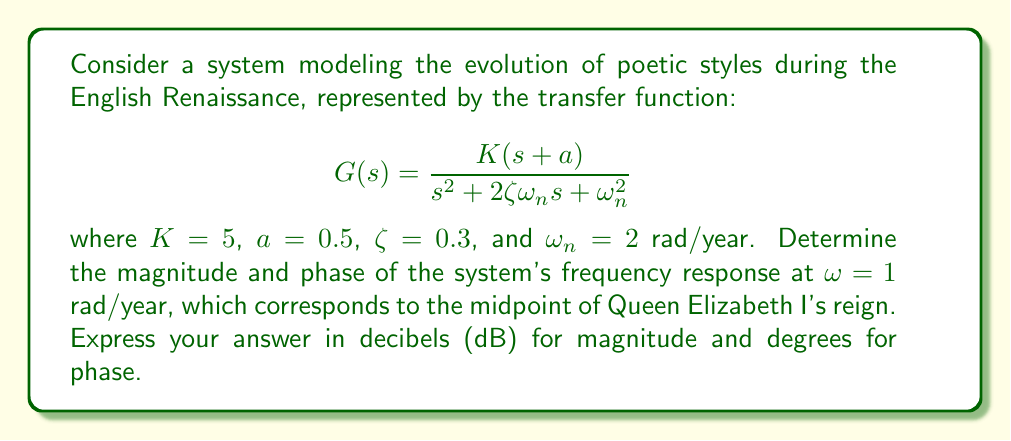Give your solution to this math problem. To solve this problem, we'll follow these steps:

1) The frequency response of a system is given by evaluating its transfer function at $s = j\omega$. Here, we need to evaluate $G(j\omega)$ at $\omega = 1$ rad/year.

2) Substituting the given values into the transfer function:

   $$G(j\omega) = \frac{5(j\omega+0.5)}{(j\omega)^2 + 2(0.3)(2)j\omega + 2^2}$$

3) Evaluating at $\omega = 1$:

   $$G(j) = \frac{5(j+0.5)}{(j)^2 + 1.2j + 4}$$

4) Simplify the numerator and denominator:

   $$G(j) = \frac{5(0.5+j)}{4-1+1.2j} = \frac{5(0.5+j)}{3+1.2j}$$

5) Multiply numerator and denominator by the complex conjugate of the denominator:

   $$G(j) = \frac{5(0.5+j)(3-1.2j)}{(3+1.2j)(3-1.2j)} = \frac{5(1.5+1.8j+0.6j-j^2)}{3^2+(1.2)^2} = \frac{5(2.5+2.4j)}{9+1.44} = \frac{12.5+12j}{10.44}$$

6) The complex number can be written as $G(j) = 1.1971 + 1.1494j$

7) The magnitude is given by $|G(j)| = \sqrt{(1.1971)^2 + (1.1494)^2} = 1.6608$

8) Convert magnitude to decibels: $20\log_{10}(1.6608) = 4.4067$ dB

9) The phase is given by $\angle G(j) = \tan^{-1}(\frac{1.1494}{1.1971}) = 0.7647$ radians

10) Convert phase to degrees: $0.7647 \times \frac{180}{\pi} = 43.8225$ degrees
Answer: Magnitude: 4.41 dB
Phase: 43.82° 